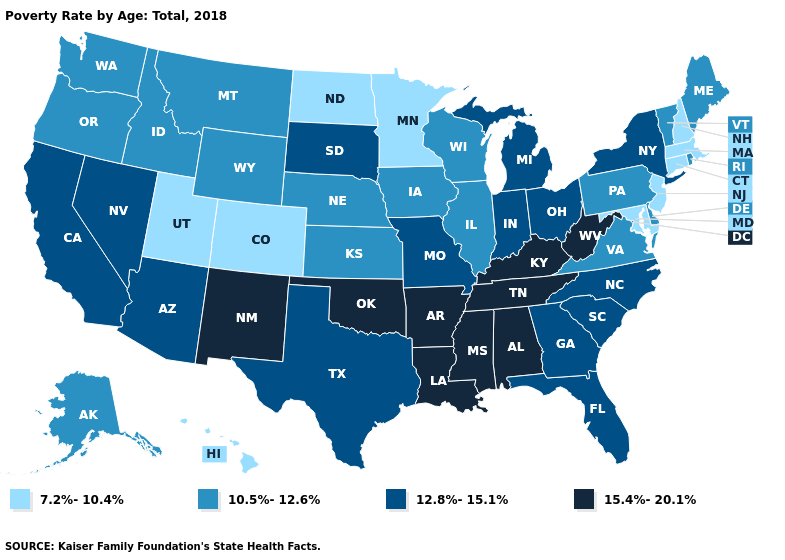Is the legend a continuous bar?
Concise answer only. No. Name the states that have a value in the range 7.2%-10.4%?
Write a very short answer. Colorado, Connecticut, Hawaii, Maryland, Massachusetts, Minnesota, New Hampshire, New Jersey, North Dakota, Utah. Name the states that have a value in the range 10.5%-12.6%?
Write a very short answer. Alaska, Delaware, Idaho, Illinois, Iowa, Kansas, Maine, Montana, Nebraska, Oregon, Pennsylvania, Rhode Island, Vermont, Virginia, Washington, Wisconsin, Wyoming. Among the states that border New York , which have the lowest value?
Be succinct. Connecticut, Massachusetts, New Jersey. Among the states that border Oregon , does Washington have the highest value?
Be succinct. No. What is the value of Idaho?
Give a very brief answer. 10.5%-12.6%. Does Virginia have a higher value than Colorado?
Give a very brief answer. Yes. Name the states that have a value in the range 15.4%-20.1%?
Keep it brief. Alabama, Arkansas, Kentucky, Louisiana, Mississippi, New Mexico, Oklahoma, Tennessee, West Virginia. What is the value of Idaho?
Quick response, please. 10.5%-12.6%. What is the highest value in the USA?
Write a very short answer. 15.4%-20.1%. What is the lowest value in the West?
Write a very short answer. 7.2%-10.4%. What is the value of Kentucky?
Write a very short answer. 15.4%-20.1%. Name the states that have a value in the range 15.4%-20.1%?
Concise answer only. Alabama, Arkansas, Kentucky, Louisiana, Mississippi, New Mexico, Oklahoma, Tennessee, West Virginia. Name the states that have a value in the range 10.5%-12.6%?
Concise answer only. Alaska, Delaware, Idaho, Illinois, Iowa, Kansas, Maine, Montana, Nebraska, Oregon, Pennsylvania, Rhode Island, Vermont, Virginia, Washington, Wisconsin, Wyoming. 